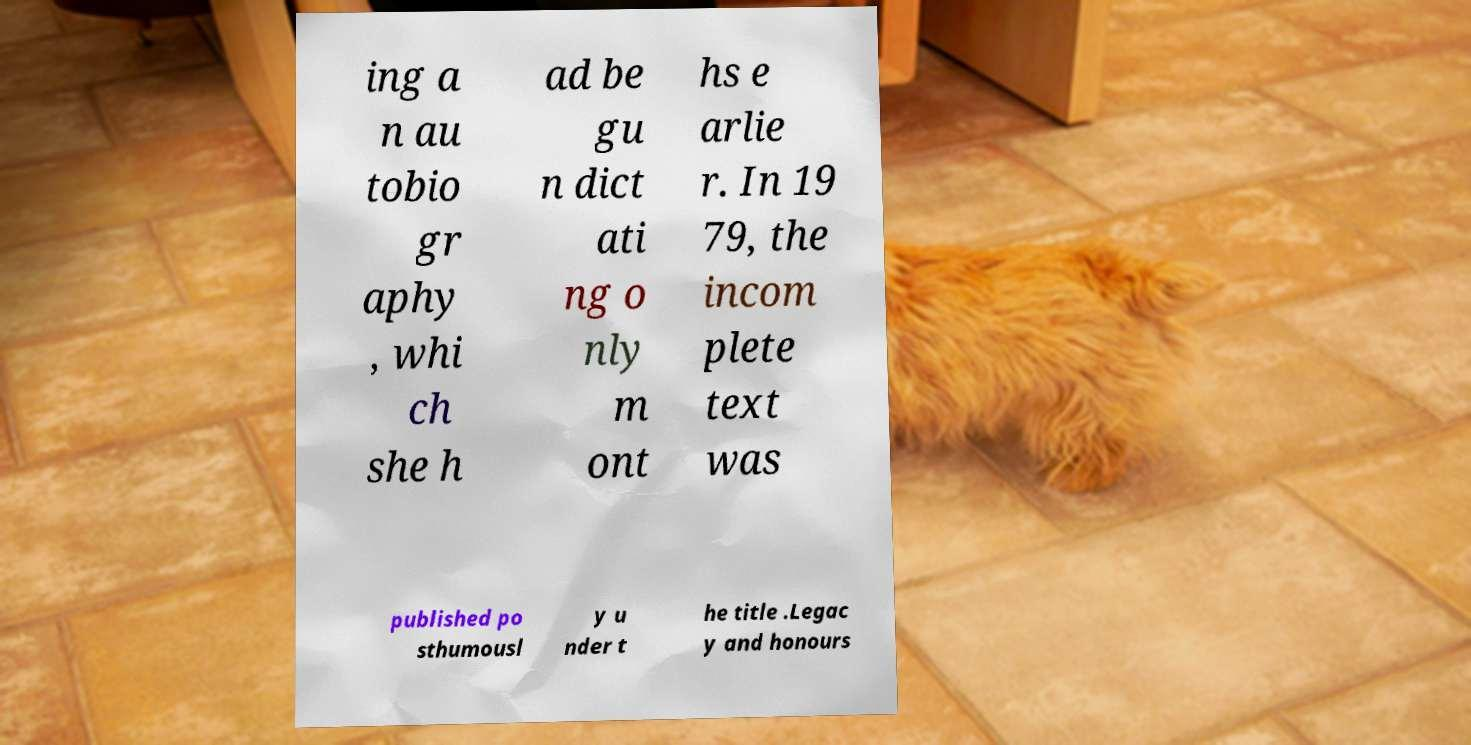Please identify and transcribe the text found in this image. ing a n au tobio gr aphy , whi ch she h ad be gu n dict ati ng o nly m ont hs e arlie r. In 19 79, the incom plete text was published po sthumousl y u nder t he title .Legac y and honours 